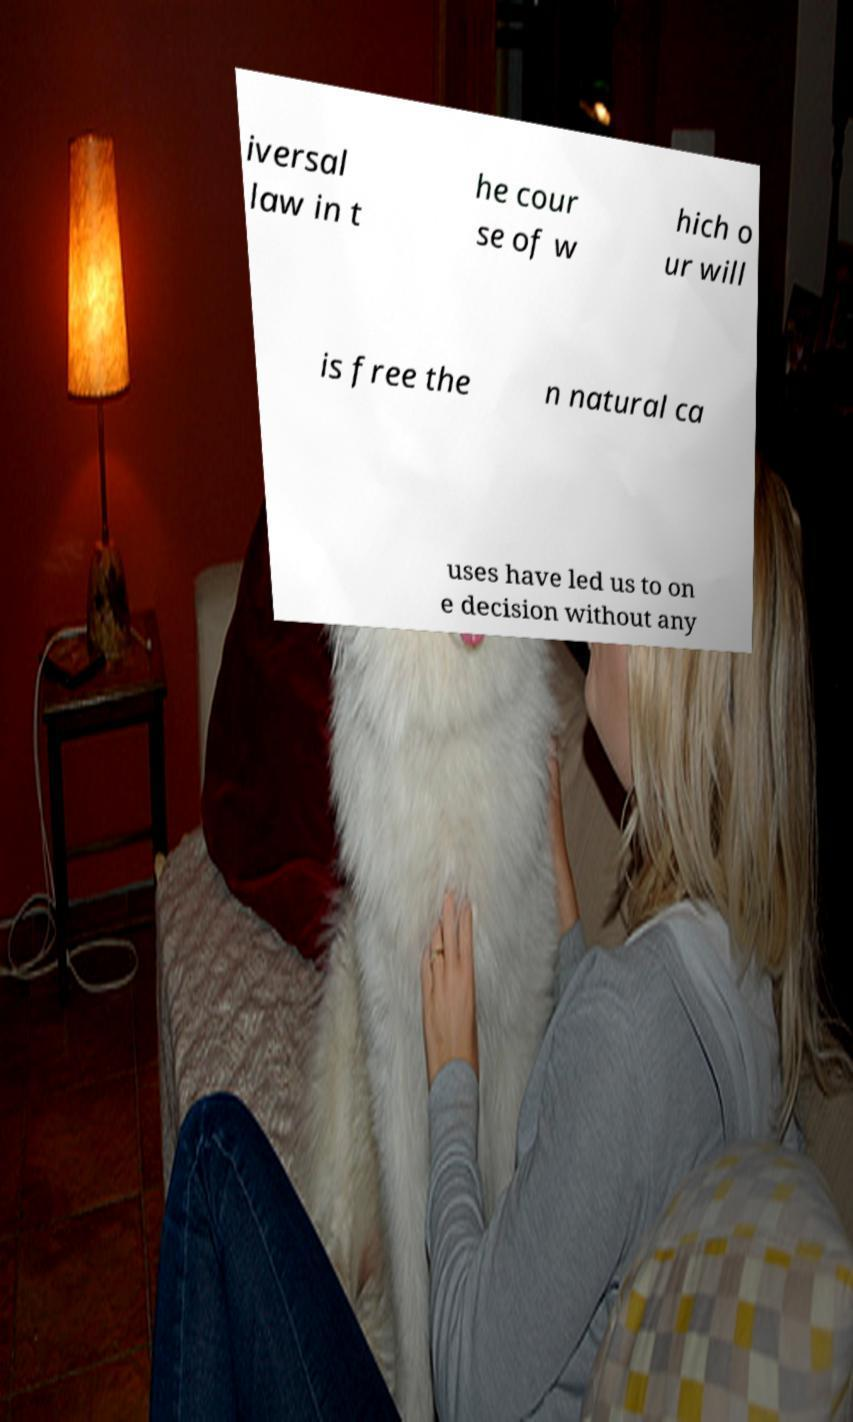Please identify and transcribe the text found in this image. iversal law in t he cour se of w hich o ur will is free the n natural ca uses have led us to on e decision without any 